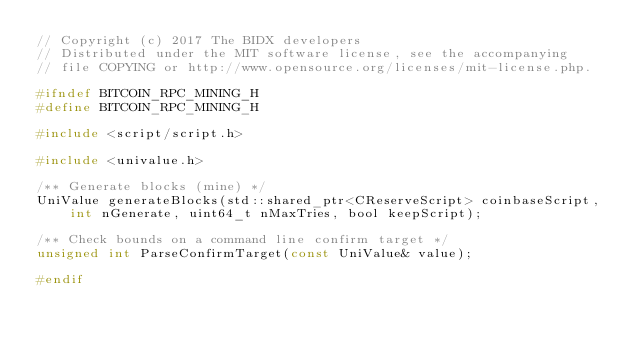Convert code to text. <code><loc_0><loc_0><loc_500><loc_500><_C_>// Copyright (c) 2017 The BIDX developers
// Distributed under the MIT software license, see the accompanying
// file COPYING or http://www.opensource.org/licenses/mit-license.php.

#ifndef BITCOIN_RPC_MINING_H
#define BITCOIN_RPC_MINING_H

#include <script/script.h>

#include <univalue.h>

/** Generate blocks (mine) */
UniValue generateBlocks(std::shared_ptr<CReserveScript> coinbaseScript, int nGenerate, uint64_t nMaxTries, bool keepScript);

/** Check bounds on a command line confirm target */
unsigned int ParseConfirmTarget(const UniValue& value);

#endif
</code> 